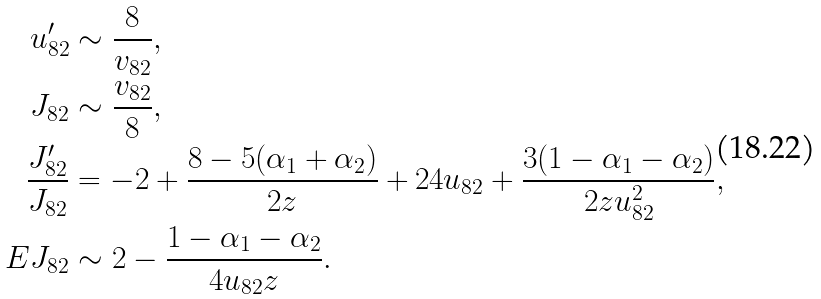<formula> <loc_0><loc_0><loc_500><loc_500>u _ { 8 2 } ^ { \prime } & \sim \frac { 8 } { v _ { 8 2 } } , \\ J _ { 8 2 } & \sim \frac { v _ { 8 2 } } { 8 } , \\ \frac { J _ { 8 2 } ^ { \prime } } { J _ { 8 2 } } & = - 2 + \frac { 8 - 5 ( \alpha _ { 1 } + \alpha _ { 2 } ) } { 2 z } + 2 4 u _ { 8 2 } + \frac { 3 ( 1 - \alpha _ { 1 } - \alpha _ { 2 } ) } { 2 z u _ { 8 2 } ^ { 2 } } , \\ E J _ { 8 2 } & \sim 2 - \frac { 1 - \alpha _ { 1 } - \alpha _ { 2 } } { 4 u _ { 8 2 } z } .</formula> 